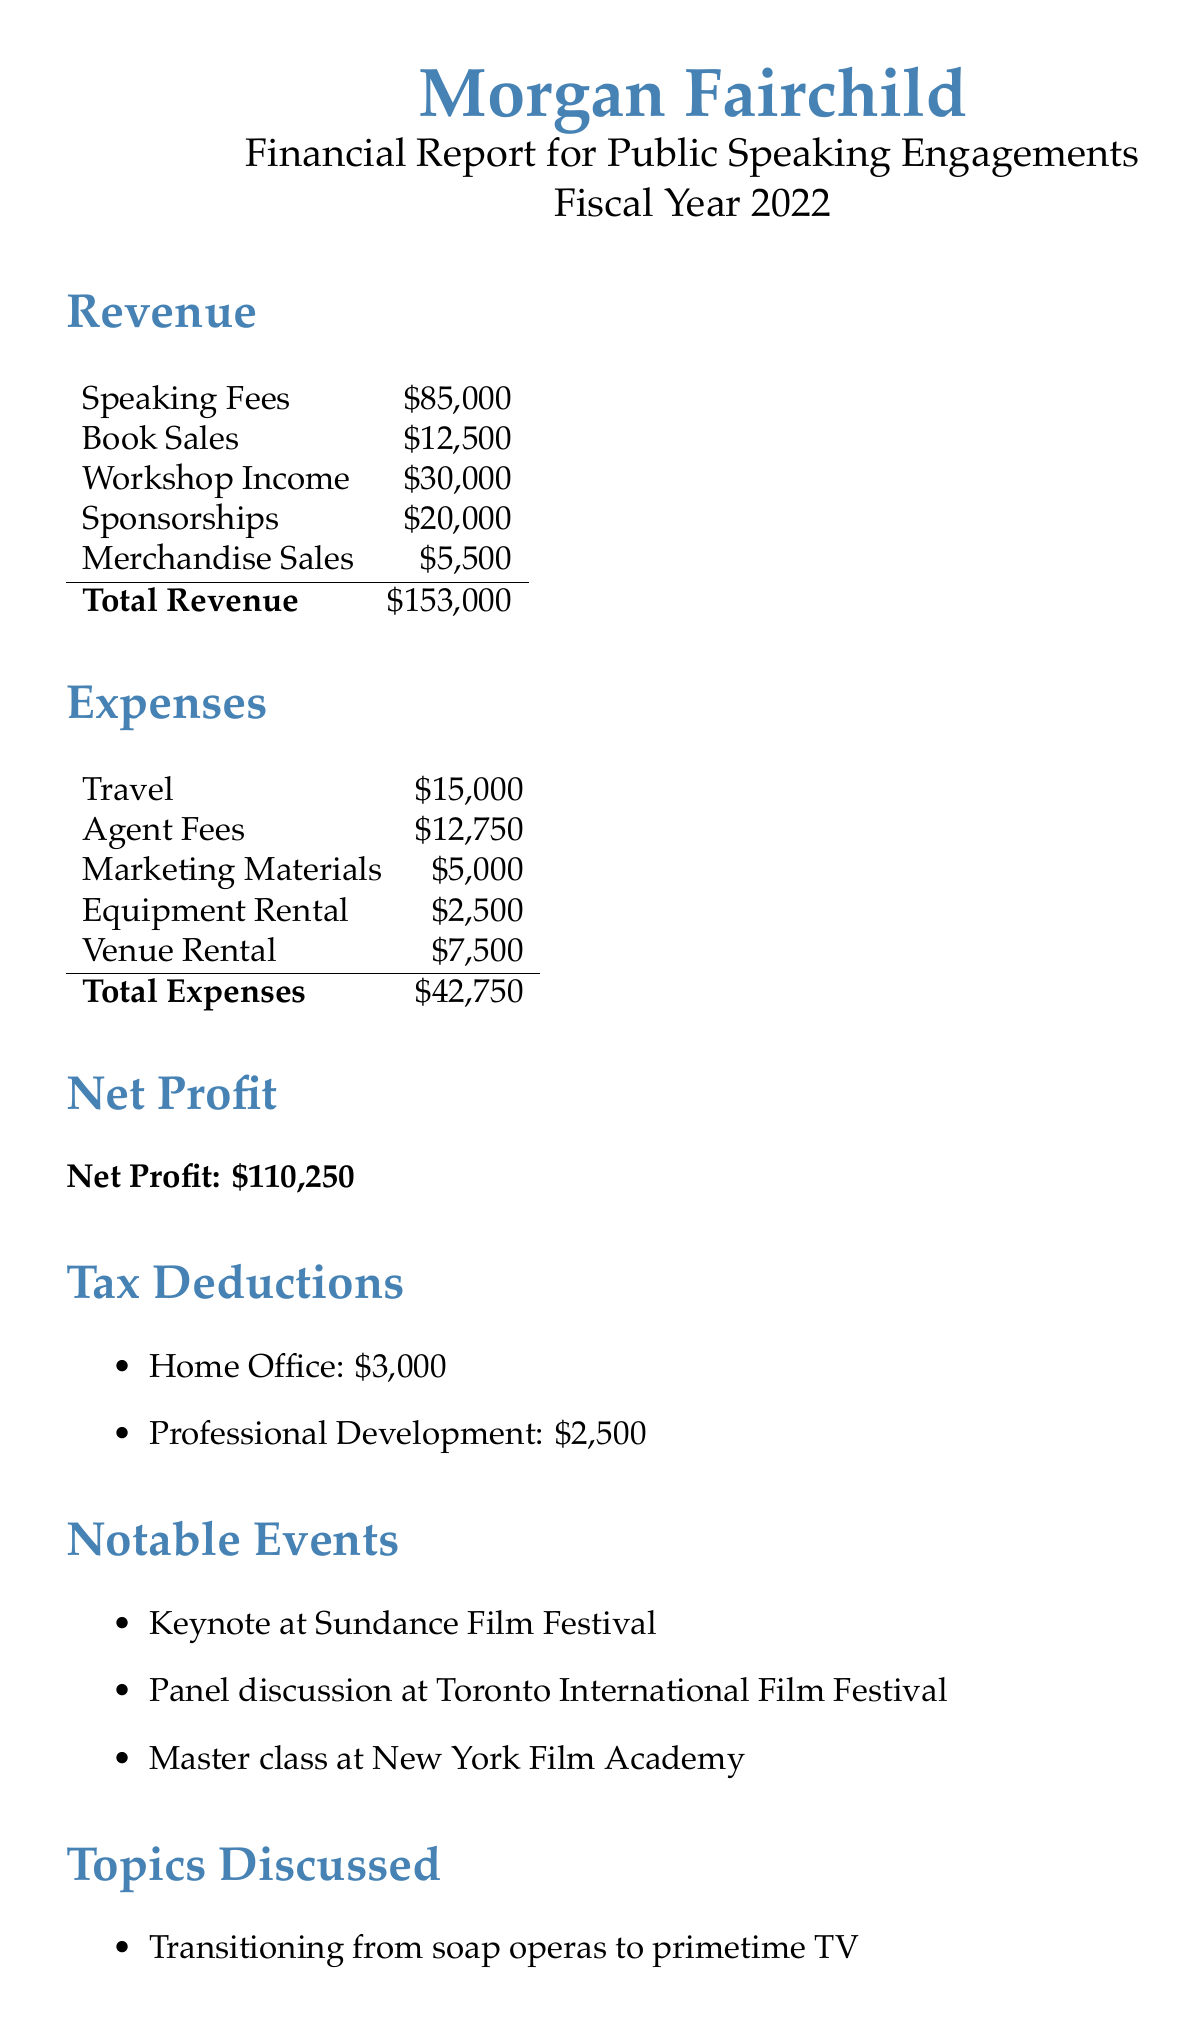What is the total revenue? The total revenue is calculated by summing the speaking fees, book sales, workshop income, sponsorships, and merchandise sales.
Answer: $153,000 What is the net profit for the fiscal year 2022? The net profit is the total revenue minus the total expenses, which is $153,000 - $42,750.
Answer: $110,250 How much was spent on travel expenses? The document specifies that travel expenses were listed, providing the exact amount spent.
Answer: $15,000 What notable event took place at the Sundance Film Festival? The document lists a notable event that occurred at Sundance Film Festival.
Answer: Keynote at Sundance Film Festival What are the topics discussed during the speaking engagements? The document lists three specific topics that were discussed, indicating the breadth of experiences shared.
Answer: Transitioning from soap operas to primetime TV What is the total amount spent on agent fees? Agent fees are itemized as a specific expense in the document, showing how much was allocated to this service.
Answer: $12,750 How many people were reached by the speaking engagements? The audience reach is stated directly in the document, indicating the total number of individuals engaged.
Answer: 5,000 What is the title of the book authored by Morgan Fairchild? The document provides the title of the book, representing a personal account of experiences in the film industry.
Answer: Crossing Lines: My Journey Through Hollywood's Genres What is the total amount for tax deductions? The tax deductions are listed separately, and the question seeks for a sum of listed deductions.
Answer: $5,500 What was the income from workshop engagements? The document specifies the revenue amount generated from workshops, a specific source of income.
Answer: $30,000 